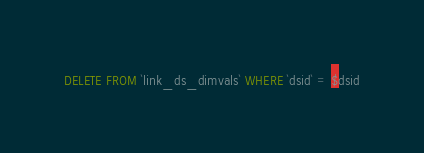<code> <loc_0><loc_0><loc_500><loc_500><_SQL_>DELETE FROM `link_ds_dimvals` WHERE `dsid` = $dsid</code> 